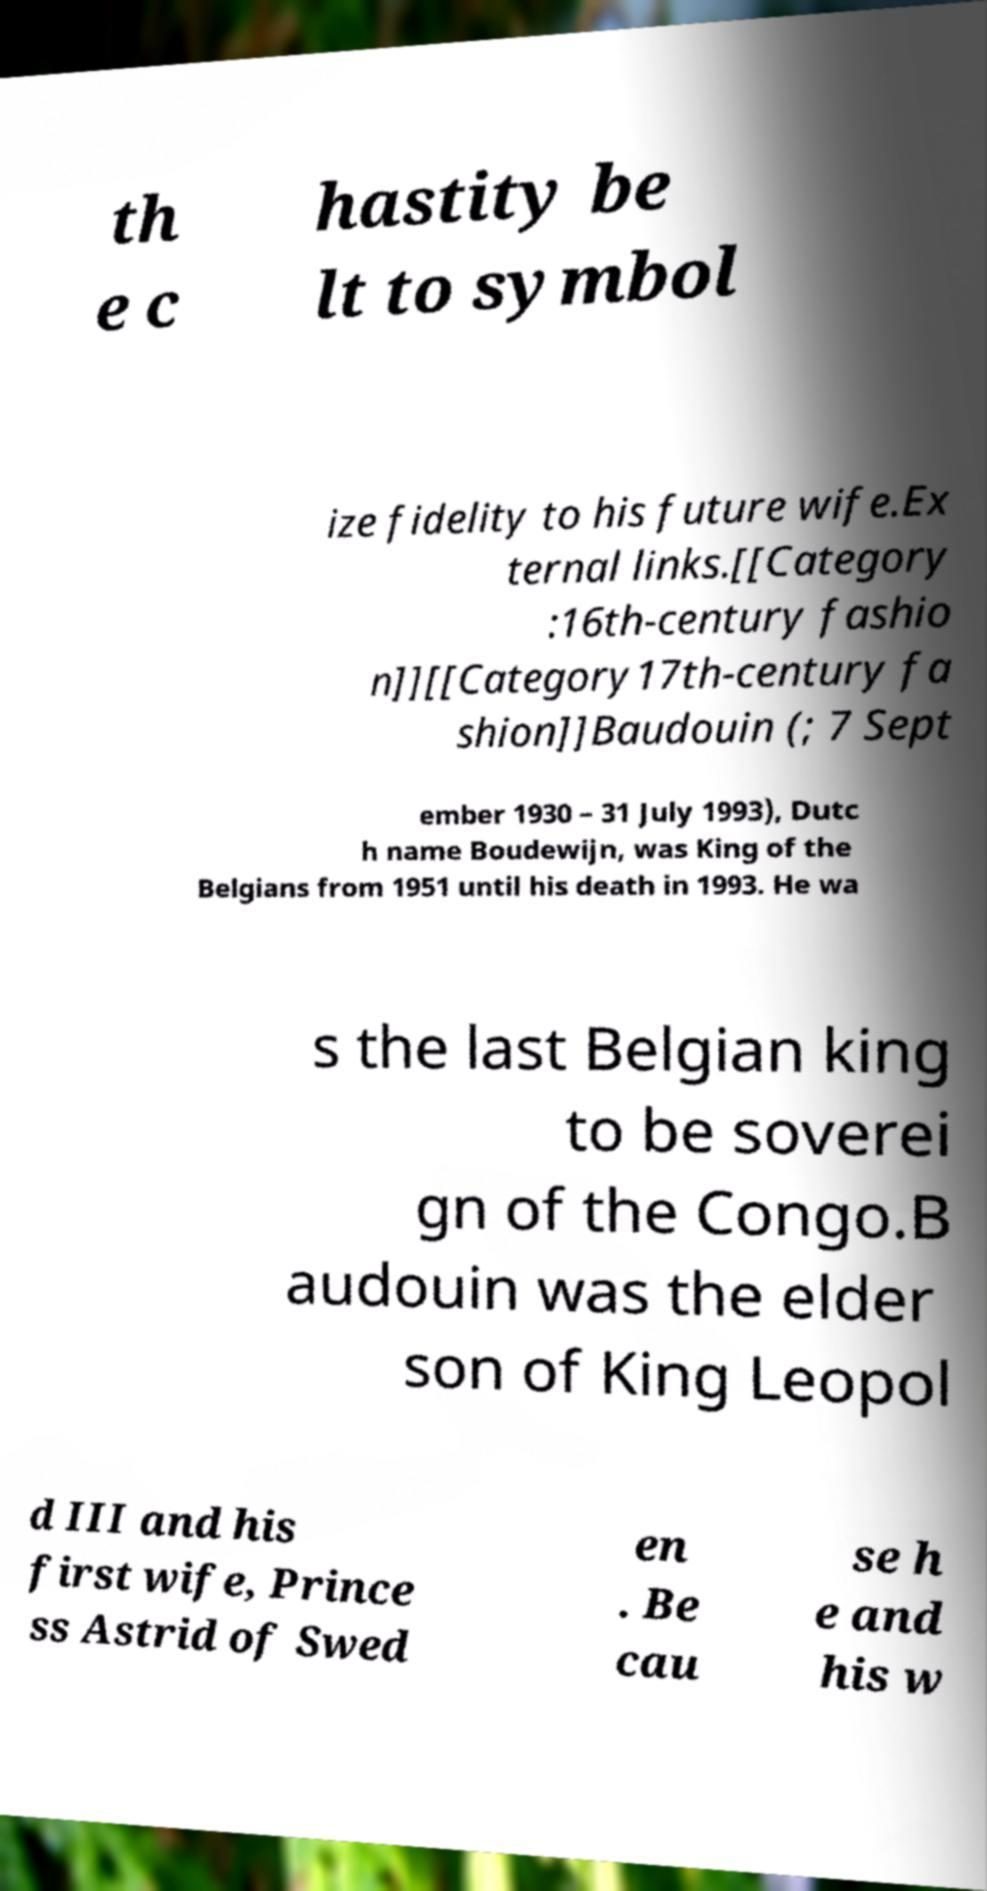Please read and relay the text visible in this image. What does it say? th e c hastity be lt to symbol ize fidelity to his future wife.Ex ternal links.[[Category :16th-century fashio n]][[Category17th-century fa shion]]Baudouin (; 7 Sept ember 1930 – 31 July 1993), Dutc h name Boudewijn, was King of the Belgians from 1951 until his death in 1993. He wa s the last Belgian king to be soverei gn of the Congo.B audouin was the elder son of King Leopol d III and his first wife, Prince ss Astrid of Swed en . Be cau se h e and his w 